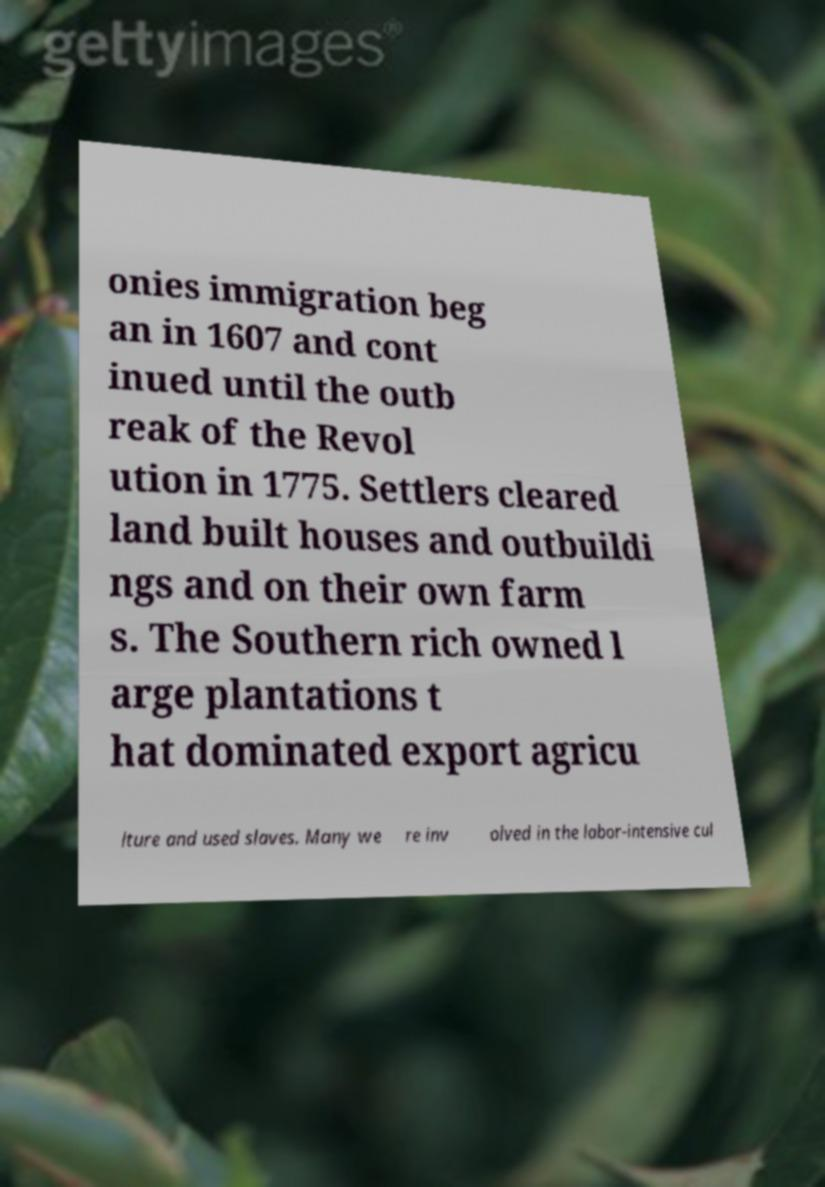Please read and relay the text visible in this image. What does it say? onies immigration beg an in 1607 and cont inued until the outb reak of the Revol ution in 1775. Settlers cleared land built houses and outbuildi ngs and on their own farm s. The Southern rich owned l arge plantations t hat dominated export agricu lture and used slaves. Many we re inv olved in the labor-intensive cul 